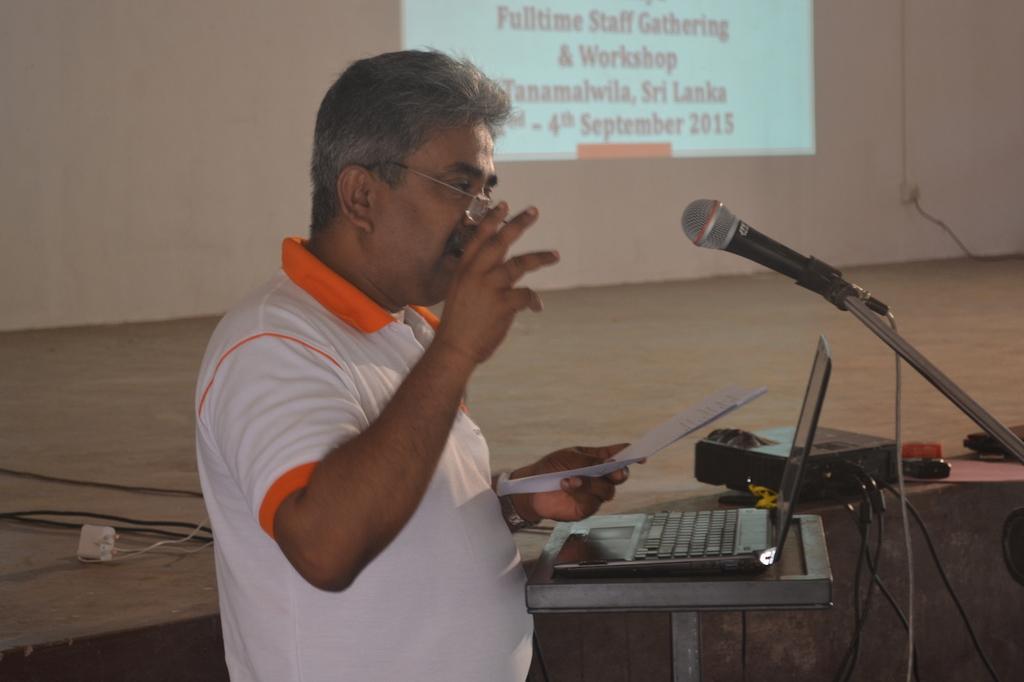Describe this image in one or two sentences. This is the man holding a paper and standing. This looks like a table with a laptop. I can see a mile, which is attached to the mike stand. This looks like a projector with the cables attached to it. This is the display on the wall. 